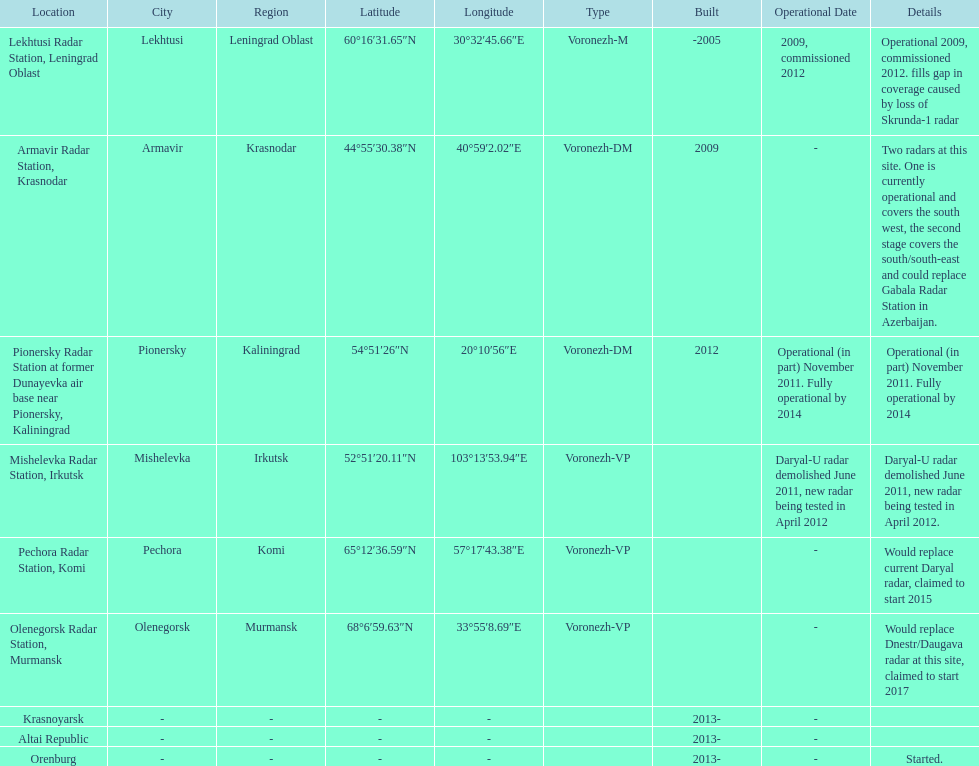What is the only location with a coordination of 60°16&#8242;31.65&#8243;n 30°32&#8242;45.66&#8243;e / 60.2754583°n 30.5460167°e? Lekhtusi Radar Station, Leningrad Oblast. 